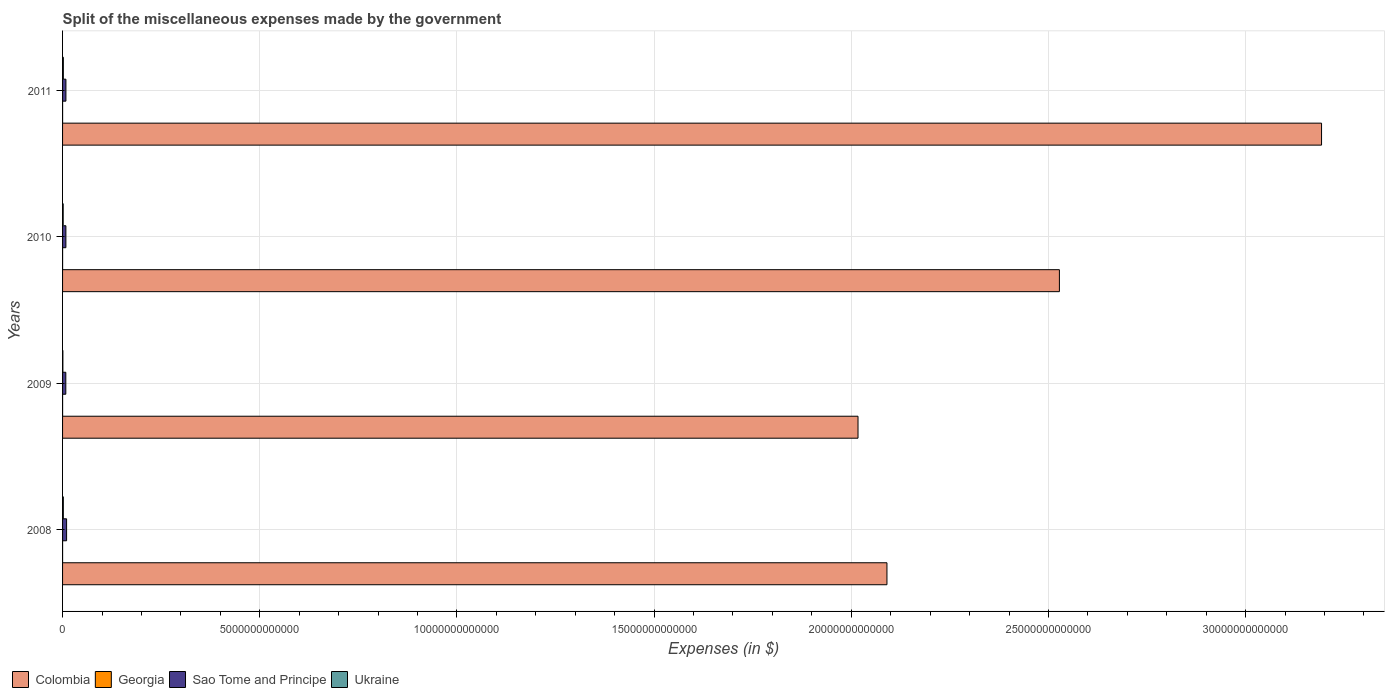How many different coloured bars are there?
Offer a very short reply. 4. Are the number of bars per tick equal to the number of legend labels?
Offer a very short reply. Yes. Are the number of bars on each tick of the Y-axis equal?
Offer a terse response. Yes. How many bars are there on the 1st tick from the top?
Your answer should be compact. 4. How many bars are there on the 3rd tick from the bottom?
Your answer should be compact. 4. What is the label of the 2nd group of bars from the top?
Give a very brief answer. 2010. What is the miscellaneous expenses made by the government in Sao Tome and Principe in 2009?
Your answer should be compact. 8.22e+1. Across all years, what is the maximum miscellaneous expenses made by the government in Sao Tome and Principe?
Provide a short and direct response. 1.02e+11. Across all years, what is the minimum miscellaneous expenses made by the government in Ukraine?
Ensure brevity in your answer.  7.82e+09. In which year was the miscellaneous expenses made by the government in Sao Tome and Principe maximum?
Your response must be concise. 2008. In which year was the miscellaneous expenses made by the government in Sao Tome and Principe minimum?
Make the answer very short. 2009. What is the total miscellaneous expenses made by the government in Georgia in the graph?
Provide a succinct answer. 2.48e+09. What is the difference between the miscellaneous expenses made by the government in Georgia in 2010 and that in 2011?
Give a very brief answer. -7.13e+07. What is the difference between the miscellaneous expenses made by the government in Colombia in 2010 and the miscellaneous expenses made by the government in Sao Tome and Principe in 2008?
Keep it short and to the point. 2.52e+13. What is the average miscellaneous expenses made by the government in Sao Tome and Principe per year?
Ensure brevity in your answer.  8.84e+1. In the year 2011, what is the difference between the miscellaneous expenses made by the government in Colombia and miscellaneous expenses made by the government in Sao Tome and Principe?
Your answer should be very brief. 3.18e+13. In how many years, is the miscellaneous expenses made by the government in Sao Tome and Principe greater than 15000000000000 $?
Your answer should be very brief. 0. What is the ratio of the miscellaneous expenses made by the government in Georgia in 2009 to that in 2010?
Provide a succinct answer. 1.1. Is the difference between the miscellaneous expenses made by the government in Colombia in 2008 and 2009 greater than the difference between the miscellaneous expenses made by the government in Sao Tome and Principe in 2008 and 2009?
Offer a very short reply. Yes. What is the difference between the highest and the second highest miscellaneous expenses made by the government in Sao Tome and Principe?
Your response must be concise. 1.71e+1. What is the difference between the highest and the lowest miscellaneous expenses made by the government in Georgia?
Provide a succinct answer. 1.79e+08. In how many years, is the miscellaneous expenses made by the government in Ukraine greater than the average miscellaneous expenses made by the government in Ukraine taken over all years?
Your answer should be compact. 3. Is the sum of the miscellaneous expenses made by the government in Sao Tome and Principe in 2009 and 2011 greater than the maximum miscellaneous expenses made by the government in Colombia across all years?
Your answer should be very brief. No. What does the 1st bar from the top in 2008 represents?
Make the answer very short. Ukraine. What does the 4th bar from the bottom in 2008 represents?
Give a very brief answer. Ukraine. Is it the case that in every year, the sum of the miscellaneous expenses made by the government in Colombia and miscellaneous expenses made by the government in Sao Tome and Principe is greater than the miscellaneous expenses made by the government in Georgia?
Make the answer very short. Yes. How many bars are there?
Offer a very short reply. 16. Are all the bars in the graph horizontal?
Offer a very short reply. Yes. How many years are there in the graph?
Offer a very short reply. 4. What is the difference between two consecutive major ticks on the X-axis?
Ensure brevity in your answer.  5.00e+12. Does the graph contain any zero values?
Your answer should be compact. No. Where does the legend appear in the graph?
Make the answer very short. Bottom left. What is the title of the graph?
Keep it short and to the point. Split of the miscellaneous expenses made by the government. What is the label or title of the X-axis?
Give a very brief answer. Expenses (in $). What is the Expenses (in $) of Colombia in 2008?
Provide a succinct answer. 2.09e+13. What is the Expenses (in $) of Georgia in 2008?
Make the answer very short. 5.06e+08. What is the Expenses (in $) in Sao Tome and Principe in 2008?
Give a very brief answer. 1.02e+11. What is the Expenses (in $) in Ukraine in 2008?
Provide a succinct answer. 1.93e+1. What is the Expenses (in $) of Colombia in 2009?
Your answer should be compact. 2.02e+13. What is the Expenses (in $) of Georgia in 2009?
Offer a terse response. 6.73e+08. What is the Expenses (in $) in Sao Tome and Principe in 2009?
Provide a short and direct response. 8.22e+1. What is the Expenses (in $) in Ukraine in 2009?
Offer a terse response. 7.82e+09. What is the Expenses (in $) in Colombia in 2010?
Provide a succinct answer. 2.53e+13. What is the Expenses (in $) in Georgia in 2010?
Make the answer very short. 6.14e+08. What is the Expenses (in $) of Sao Tome and Principe in 2010?
Make the answer very short. 8.44e+1. What is the Expenses (in $) in Ukraine in 2010?
Give a very brief answer. 1.56e+1. What is the Expenses (in $) in Colombia in 2011?
Offer a terse response. 3.19e+13. What is the Expenses (in $) of Georgia in 2011?
Offer a very short reply. 6.85e+08. What is the Expenses (in $) of Sao Tome and Principe in 2011?
Your response must be concise. 8.49e+1. What is the Expenses (in $) of Ukraine in 2011?
Make the answer very short. 1.96e+1. Across all years, what is the maximum Expenses (in $) of Colombia?
Provide a short and direct response. 3.19e+13. Across all years, what is the maximum Expenses (in $) of Georgia?
Provide a succinct answer. 6.85e+08. Across all years, what is the maximum Expenses (in $) in Sao Tome and Principe?
Offer a terse response. 1.02e+11. Across all years, what is the maximum Expenses (in $) in Ukraine?
Keep it short and to the point. 1.96e+1. Across all years, what is the minimum Expenses (in $) in Colombia?
Your response must be concise. 2.02e+13. Across all years, what is the minimum Expenses (in $) in Georgia?
Offer a terse response. 5.06e+08. Across all years, what is the minimum Expenses (in $) in Sao Tome and Principe?
Make the answer very short. 8.22e+1. Across all years, what is the minimum Expenses (in $) in Ukraine?
Your answer should be compact. 7.82e+09. What is the total Expenses (in $) of Colombia in the graph?
Give a very brief answer. 9.83e+13. What is the total Expenses (in $) of Georgia in the graph?
Ensure brevity in your answer.  2.48e+09. What is the total Expenses (in $) of Sao Tome and Principe in the graph?
Your answer should be compact. 3.54e+11. What is the total Expenses (in $) of Ukraine in the graph?
Provide a short and direct response. 6.23e+1. What is the difference between the Expenses (in $) in Colombia in 2008 and that in 2009?
Provide a succinct answer. 7.33e+11. What is the difference between the Expenses (in $) of Georgia in 2008 and that in 2009?
Keep it short and to the point. -1.67e+08. What is the difference between the Expenses (in $) in Sao Tome and Principe in 2008 and that in 2009?
Make the answer very short. 1.99e+1. What is the difference between the Expenses (in $) in Ukraine in 2008 and that in 2009?
Your response must be concise. 1.15e+1. What is the difference between the Expenses (in $) of Colombia in 2008 and that in 2010?
Offer a terse response. -4.37e+12. What is the difference between the Expenses (in $) in Georgia in 2008 and that in 2010?
Offer a very short reply. -1.08e+08. What is the difference between the Expenses (in $) in Sao Tome and Principe in 2008 and that in 2010?
Offer a very short reply. 1.77e+1. What is the difference between the Expenses (in $) of Ukraine in 2008 and that in 2010?
Give a very brief answer. 3.77e+09. What is the difference between the Expenses (in $) of Colombia in 2008 and that in 2011?
Your answer should be very brief. -1.10e+13. What is the difference between the Expenses (in $) of Georgia in 2008 and that in 2011?
Keep it short and to the point. -1.79e+08. What is the difference between the Expenses (in $) in Sao Tome and Principe in 2008 and that in 2011?
Provide a succinct answer. 1.71e+1. What is the difference between the Expenses (in $) of Ukraine in 2008 and that in 2011?
Your answer should be compact. -2.13e+08. What is the difference between the Expenses (in $) of Colombia in 2009 and that in 2010?
Give a very brief answer. -5.11e+12. What is the difference between the Expenses (in $) of Georgia in 2009 and that in 2010?
Provide a succinct answer. 5.92e+07. What is the difference between the Expenses (in $) of Sao Tome and Principe in 2009 and that in 2010?
Give a very brief answer. -2.19e+09. What is the difference between the Expenses (in $) in Ukraine in 2009 and that in 2010?
Make the answer very short. -7.76e+09. What is the difference between the Expenses (in $) of Colombia in 2009 and that in 2011?
Your response must be concise. -1.18e+13. What is the difference between the Expenses (in $) of Georgia in 2009 and that in 2011?
Keep it short and to the point. -1.21e+07. What is the difference between the Expenses (in $) in Sao Tome and Principe in 2009 and that in 2011?
Your response must be concise. -2.74e+09. What is the difference between the Expenses (in $) of Ukraine in 2009 and that in 2011?
Offer a terse response. -1.17e+1. What is the difference between the Expenses (in $) in Colombia in 2010 and that in 2011?
Your answer should be very brief. -6.65e+12. What is the difference between the Expenses (in $) in Georgia in 2010 and that in 2011?
Offer a terse response. -7.13e+07. What is the difference between the Expenses (in $) in Sao Tome and Principe in 2010 and that in 2011?
Keep it short and to the point. -5.56e+08. What is the difference between the Expenses (in $) of Ukraine in 2010 and that in 2011?
Your answer should be very brief. -3.98e+09. What is the difference between the Expenses (in $) in Colombia in 2008 and the Expenses (in $) in Georgia in 2009?
Your response must be concise. 2.09e+13. What is the difference between the Expenses (in $) in Colombia in 2008 and the Expenses (in $) in Sao Tome and Principe in 2009?
Provide a short and direct response. 2.08e+13. What is the difference between the Expenses (in $) in Colombia in 2008 and the Expenses (in $) in Ukraine in 2009?
Give a very brief answer. 2.09e+13. What is the difference between the Expenses (in $) of Georgia in 2008 and the Expenses (in $) of Sao Tome and Principe in 2009?
Give a very brief answer. -8.17e+1. What is the difference between the Expenses (in $) of Georgia in 2008 and the Expenses (in $) of Ukraine in 2009?
Your answer should be very brief. -7.31e+09. What is the difference between the Expenses (in $) in Sao Tome and Principe in 2008 and the Expenses (in $) in Ukraine in 2009?
Ensure brevity in your answer.  9.42e+1. What is the difference between the Expenses (in $) of Colombia in 2008 and the Expenses (in $) of Georgia in 2010?
Keep it short and to the point. 2.09e+13. What is the difference between the Expenses (in $) of Colombia in 2008 and the Expenses (in $) of Sao Tome and Principe in 2010?
Provide a short and direct response. 2.08e+13. What is the difference between the Expenses (in $) of Colombia in 2008 and the Expenses (in $) of Ukraine in 2010?
Your response must be concise. 2.09e+13. What is the difference between the Expenses (in $) in Georgia in 2008 and the Expenses (in $) in Sao Tome and Principe in 2010?
Your answer should be very brief. -8.39e+1. What is the difference between the Expenses (in $) of Georgia in 2008 and the Expenses (in $) of Ukraine in 2010?
Give a very brief answer. -1.51e+1. What is the difference between the Expenses (in $) in Sao Tome and Principe in 2008 and the Expenses (in $) in Ukraine in 2010?
Give a very brief answer. 8.65e+1. What is the difference between the Expenses (in $) in Colombia in 2008 and the Expenses (in $) in Georgia in 2011?
Make the answer very short. 2.09e+13. What is the difference between the Expenses (in $) of Colombia in 2008 and the Expenses (in $) of Sao Tome and Principe in 2011?
Offer a very short reply. 2.08e+13. What is the difference between the Expenses (in $) in Colombia in 2008 and the Expenses (in $) in Ukraine in 2011?
Make the answer very short. 2.09e+13. What is the difference between the Expenses (in $) of Georgia in 2008 and the Expenses (in $) of Sao Tome and Principe in 2011?
Offer a terse response. -8.44e+1. What is the difference between the Expenses (in $) in Georgia in 2008 and the Expenses (in $) in Ukraine in 2011?
Provide a short and direct response. -1.91e+1. What is the difference between the Expenses (in $) of Sao Tome and Principe in 2008 and the Expenses (in $) of Ukraine in 2011?
Offer a terse response. 8.25e+1. What is the difference between the Expenses (in $) in Colombia in 2009 and the Expenses (in $) in Georgia in 2010?
Provide a succinct answer. 2.02e+13. What is the difference between the Expenses (in $) of Colombia in 2009 and the Expenses (in $) of Sao Tome and Principe in 2010?
Offer a terse response. 2.01e+13. What is the difference between the Expenses (in $) of Colombia in 2009 and the Expenses (in $) of Ukraine in 2010?
Ensure brevity in your answer.  2.02e+13. What is the difference between the Expenses (in $) of Georgia in 2009 and the Expenses (in $) of Sao Tome and Principe in 2010?
Provide a short and direct response. -8.37e+1. What is the difference between the Expenses (in $) of Georgia in 2009 and the Expenses (in $) of Ukraine in 2010?
Provide a short and direct response. -1.49e+1. What is the difference between the Expenses (in $) in Sao Tome and Principe in 2009 and the Expenses (in $) in Ukraine in 2010?
Your answer should be compact. 6.66e+1. What is the difference between the Expenses (in $) of Colombia in 2009 and the Expenses (in $) of Georgia in 2011?
Make the answer very short. 2.02e+13. What is the difference between the Expenses (in $) in Colombia in 2009 and the Expenses (in $) in Sao Tome and Principe in 2011?
Ensure brevity in your answer.  2.01e+13. What is the difference between the Expenses (in $) of Colombia in 2009 and the Expenses (in $) of Ukraine in 2011?
Give a very brief answer. 2.02e+13. What is the difference between the Expenses (in $) in Georgia in 2009 and the Expenses (in $) in Sao Tome and Principe in 2011?
Keep it short and to the point. -8.43e+1. What is the difference between the Expenses (in $) of Georgia in 2009 and the Expenses (in $) of Ukraine in 2011?
Provide a succinct answer. -1.89e+1. What is the difference between the Expenses (in $) of Sao Tome and Principe in 2009 and the Expenses (in $) of Ukraine in 2011?
Your answer should be compact. 6.26e+1. What is the difference between the Expenses (in $) in Colombia in 2010 and the Expenses (in $) in Georgia in 2011?
Ensure brevity in your answer.  2.53e+13. What is the difference between the Expenses (in $) in Colombia in 2010 and the Expenses (in $) in Sao Tome and Principe in 2011?
Give a very brief answer. 2.52e+13. What is the difference between the Expenses (in $) in Colombia in 2010 and the Expenses (in $) in Ukraine in 2011?
Your answer should be compact. 2.53e+13. What is the difference between the Expenses (in $) in Georgia in 2010 and the Expenses (in $) in Sao Tome and Principe in 2011?
Ensure brevity in your answer.  -8.43e+1. What is the difference between the Expenses (in $) of Georgia in 2010 and the Expenses (in $) of Ukraine in 2011?
Make the answer very short. -1.89e+1. What is the difference between the Expenses (in $) in Sao Tome and Principe in 2010 and the Expenses (in $) in Ukraine in 2011?
Offer a very short reply. 6.48e+1. What is the average Expenses (in $) of Colombia per year?
Offer a very short reply. 2.46e+13. What is the average Expenses (in $) of Georgia per year?
Give a very brief answer. 6.19e+08. What is the average Expenses (in $) of Sao Tome and Principe per year?
Provide a short and direct response. 8.84e+1. What is the average Expenses (in $) of Ukraine per year?
Give a very brief answer. 1.56e+1. In the year 2008, what is the difference between the Expenses (in $) in Colombia and Expenses (in $) in Georgia?
Make the answer very short. 2.09e+13. In the year 2008, what is the difference between the Expenses (in $) in Colombia and Expenses (in $) in Sao Tome and Principe?
Ensure brevity in your answer.  2.08e+13. In the year 2008, what is the difference between the Expenses (in $) in Colombia and Expenses (in $) in Ukraine?
Make the answer very short. 2.09e+13. In the year 2008, what is the difference between the Expenses (in $) in Georgia and Expenses (in $) in Sao Tome and Principe?
Offer a very short reply. -1.02e+11. In the year 2008, what is the difference between the Expenses (in $) of Georgia and Expenses (in $) of Ukraine?
Make the answer very short. -1.88e+1. In the year 2008, what is the difference between the Expenses (in $) of Sao Tome and Principe and Expenses (in $) of Ukraine?
Your response must be concise. 8.27e+1. In the year 2009, what is the difference between the Expenses (in $) in Colombia and Expenses (in $) in Georgia?
Keep it short and to the point. 2.02e+13. In the year 2009, what is the difference between the Expenses (in $) in Colombia and Expenses (in $) in Sao Tome and Principe?
Offer a terse response. 2.01e+13. In the year 2009, what is the difference between the Expenses (in $) in Colombia and Expenses (in $) in Ukraine?
Give a very brief answer. 2.02e+13. In the year 2009, what is the difference between the Expenses (in $) of Georgia and Expenses (in $) of Sao Tome and Principe?
Your response must be concise. -8.15e+1. In the year 2009, what is the difference between the Expenses (in $) in Georgia and Expenses (in $) in Ukraine?
Give a very brief answer. -7.15e+09. In the year 2009, what is the difference between the Expenses (in $) in Sao Tome and Principe and Expenses (in $) in Ukraine?
Provide a short and direct response. 7.44e+1. In the year 2010, what is the difference between the Expenses (in $) of Colombia and Expenses (in $) of Georgia?
Offer a very short reply. 2.53e+13. In the year 2010, what is the difference between the Expenses (in $) in Colombia and Expenses (in $) in Sao Tome and Principe?
Your answer should be compact. 2.52e+13. In the year 2010, what is the difference between the Expenses (in $) in Colombia and Expenses (in $) in Ukraine?
Your answer should be very brief. 2.53e+13. In the year 2010, what is the difference between the Expenses (in $) of Georgia and Expenses (in $) of Sao Tome and Principe?
Your answer should be compact. -8.38e+1. In the year 2010, what is the difference between the Expenses (in $) in Georgia and Expenses (in $) in Ukraine?
Ensure brevity in your answer.  -1.50e+1. In the year 2010, what is the difference between the Expenses (in $) of Sao Tome and Principe and Expenses (in $) of Ukraine?
Keep it short and to the point. 6.88e+1. In the year 2011, what is the difference between the Expenses (in $) in Colombia and Expenses (in $) in Georgia?
Offer a very short reply. 3.19e+13. In the year 2011, what is the difference between the Expenses (in $) of Colombia and Expenses (in $) of Sao Tome and Principe?
Your response must be concise. 3.18e+13. In the year 2011, what is the difference between the Expenses (in $) in Colombia and Expenses (in $) in Ukraine?
Offer a very short reply. 3.19e+13. In the year 2011, what is the difference between the Expenses (in $) of Georgia and Expenses (in $) of Sao Tome and Principe?
Your answer should be very brief. -8.42e+1. In the year 2011, what is the difference between the Expenses (in $) of Georgia and Expenses (in $) of Ukraine?
Make the answer very short. -1.89e+1. In the year 2011, what is the difference between the Expenses (in $) of Sao Tome and Principe and Expenses (in $) of Ukraine?
Make the answer very short. 6.54e+1. What is the ratio of the Expenses (in $) of Colombia in 2008 to that in 2009?
Your answer should be very brief. 1.04. What is the ratio of the Expenses (in $) of Georgia in 2008 to that in 2009?
Offer a terse response. 0.75. What is the ratio of the Expenses (in $) in Sao Tome and Principe in 2008 to that in 2009?
Offer a terse response. 1.24. What is the ratio of the Expenses (in $) in Ukraine in 2008 to that in 2009?
Offer a terse response. 2.47. What is the ratio of the Expenses (in $) in Colombia in 2008 to that in 2010?
Offer a terse response. 0.83. What is the ratio of the Expenses (in $) in Georgia in 2008 to that in 2010?
Offer a very short reply. 0.82. What is the ratio of the Expenses (in $) in Sao Tome and Principe in 2008 to that in 2010?
Give a very brief answer. 1.21. What is the ratio of the Expenses (in $) of Ukraine in 2008 to that in 2010?
Provide a short and direct response. 1.24. What is the ratio of the Expenses (in $) of Colombia in 2008 to that in 2011?
Provide a succinct answer. 0.65. What is the ratio of the Expenses (in $) in Georgia in 2008 to that in 2011?
Provide a succinct answer. 0.74. What is the ratio of the Expenses (in $) in Sao Tome and Principe in 2008 to that in 2011?
Provide a short and direct response. 1.2. What is the ratio of the Expenses (in $) of Ukraine in 2008 to that in 2011?
Your answer should be compact. 0.99. What is the ratio of the Expenses (in $) of Colombia in 2009 to that in 2010?
Ensure brevity in your answer.  0.8. What is the ratio of the Expenses (in $) in Georgia in 2009 to that in 2010?
Offer a terse response. 1.1. What is the ratio of the Expenses (in $) in Sao Tome and Principe in 2009 to that in 2010?
Your response must be concise. 0.97. What is the ratio of the Expenses (in $) in Ukraine in 2009 to that in 2010?
Offer a very short reply. 0.5. What is the ratio of the Expenses (in $) in Colombia in 2009 to that in 2011?
Give a very brief answer. 0.63. What is the ratio of the Expenses (in $) in Georgia in 2009 to that in 2011?
Ensure brevity in your answer.  0.98. What is the ratio of the Expenses (in $) in Sao Tome and Principe in 2009 to that in 2011?
Your answer should be compact. 0.97. What is the ratio of the Expenses (in $) in Ukraine in 2009 to that in 2011?
Provide a short and direct response. 0.4. What is the ratio of the Expenses (in $) in Colombia in 2010 to that in 2011?
Ensure brevity in your answer.  0.79. What is the ratio of the Expenses (in $) of Georgia in 2010 to that in 2011?
Make the answer very short. 0.9. What is the ratio of the Expenses (in $) in Sao Tome and Principe in 2010 to that in 2011?
Ensure brevity in your answer.  0.99. What is the ratio of the Expenses (in $) of Ukraine in 2010 to that in 2011?
Your answer should be compact. 0.8. What is the difference between the highest and the second highest Expenses (in $) in Colombia?
Your answer should be very brief. 6.65e+12. What is the difference between the highest and the second highest Expenses (in $) in Georgia?
Give a very brief answer. 1.21e+07. What is the difference between the highest and the second highest Expenses (in $) of Sao Tome and Principe?
Ensure brevity in your answer.  1.71e+1. What is the difference between the highest and the second highest Expenses (in $) of Ukraine?
Your answer should be compact. 2.13e+08. What is the difference between the highest and the lowest Expenses (in $) of Colombia?
Your answer should be very brief. 1.18e+13. What is the difference between the highest and the lowest Expenses (in $) in Georgia?
Offer a very short reply. 1.79e+08. What is the difference between the highest and the lowest Expenses (in $) of Sao Tome and Principe?
Your answer should be very brief. 1.99e+1. What is the difference between the highest and the lowest Expenses (in $) in Ukraine?
Your answer should be compact. 1.17e+1. 